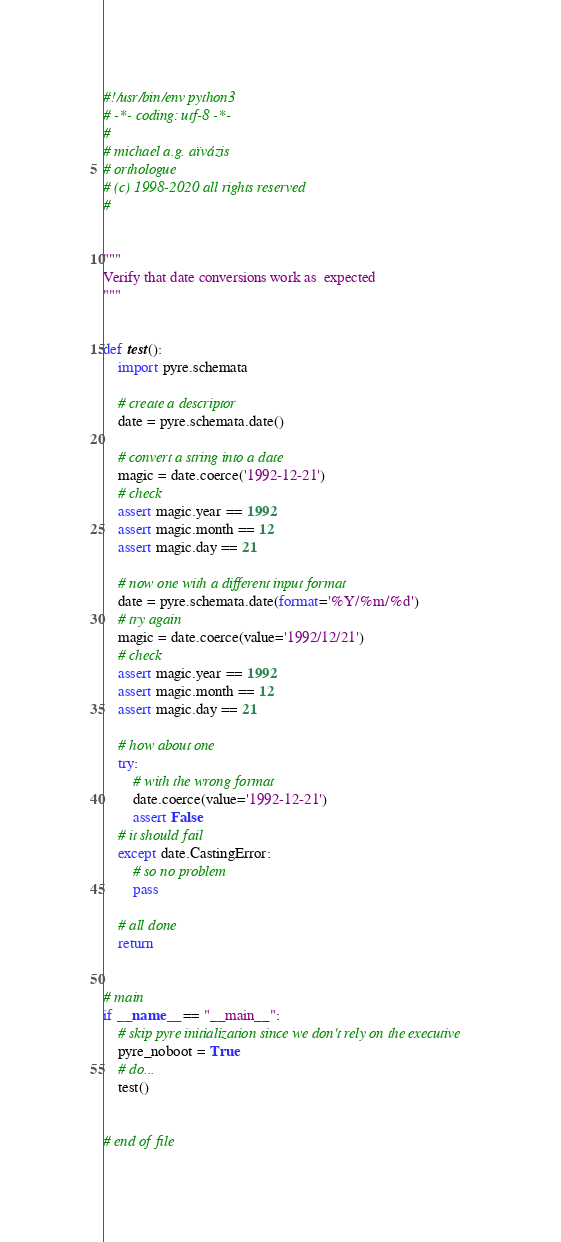<code> <loc_0><loc_0><loc_500><loc_500><_Python_>#!/usr/bin/env python3
# -*- coding: utf-8 -*-
#
# michael a.g. aïvázis
# orthologue
# (c) 1998-2020 all rights reserved
#


"""
Verify that date conversions work as  expected
"""


def test():
    import pyre.schemata

    # create a descriptor
    date = pyre.schemata.date()

    # convert a string into a date
    magic = date.coerce('1992-12-21')
    # check
    assert magic.year == 1992
    assert magic.month == 12
    assert magic.day == 21

    # now one with a different input format
    date = pyre.schemata.date(format='%Y/%m/%d')
    # try again
    magic = date.coerce(value='1992/12/21')
    # check
    assert magic.year == 1992
    assert magic.month == 12
    assert magic.day == 21

    # how about one
    try:
        # with the wrong format
        date.coerce(value='1992-12-21')
        assert False
    # it should fail
    except date.CastingError:
        # so no problem
        pass

    # all done
    return


# main
if __name__ == "__main__":
    # skip pyre initialization since we don't rely on the executive
    pyre_noboot = True
    # do...
    test()


# end of file
</code> 